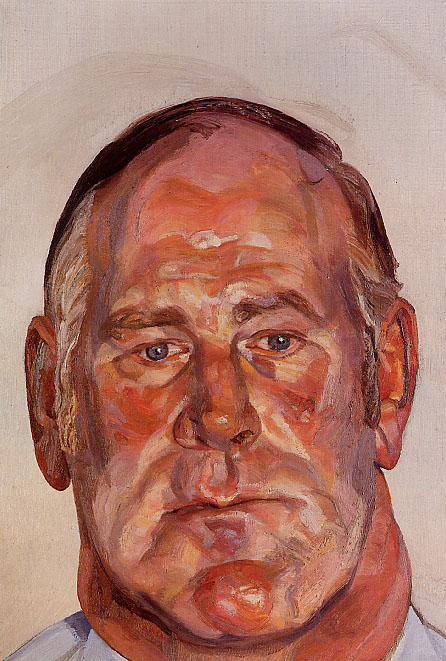Can you describe the technique used in this painting? This painting employs an expressionist technique that utilizes oil on canvas as the medium. The artist has used thick, textured brushstrokes to apply the paint, creating a highly dynamic and tactile surface. The use of warm colors such as orange, red, and pink enhances the emotional intensity of the portrait, drawing the viewer's attention to the man's face and its expressive details. The background is left relatively plain and in a pale beige, which helps to further emphasize the vibrancy and texture of the central figure. This method of painting, marked by its emphasis on individual brushstrokes and emotional expression, is a hallmark of the expressionist movement. 